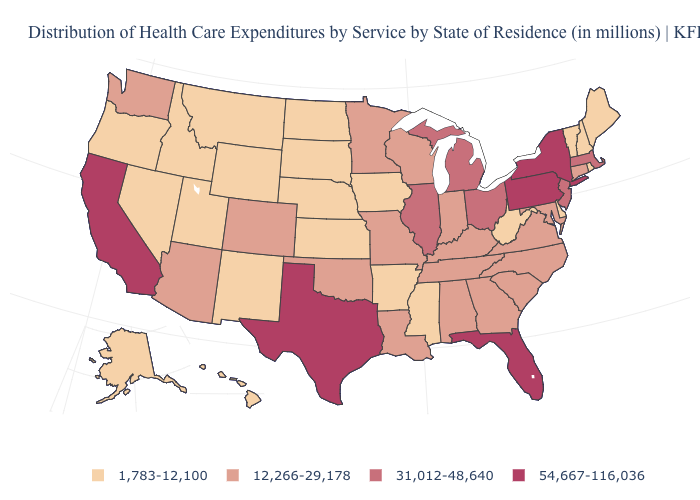Is the legend a continuous bar?
Quick response, please. No. Among the states that border Rhode Island , which have the highest value?
Be succinct. Massachusetts. What is the highest value in the USA?
Be succinct. 54,667-116,036. Name the states that have a value in the range 12,266-29,178?
Answer briefly. Alabama, Arizona, Colorado, Connecticut, Georgia, Indiana, Kentucky, Louisiana, Maryland, Minnesota, Missouri, North Carolina, Oklahoma, South Carolina, Tennessee, Virginia, Washington, Wisconsin. What is the highest value in states that border Delaware?
Write a very short answer. 54,667-116,036. Does California have the highest value in the West?
Give a very brief answer. Yes. Which states have the lowest value in the MidWest?
Quick response, please. Iowa, Kansas, Nebraska, North Dakota, South Dakota. What is the lowest value in the USA?
Keep it brief. 1,783-12,100. Which states hav the highest value in the MidWest?
Be succinct. Illinois, Michigan, Ohio. Does Michigan have the lowest value in the USA?
Quick response, please. No. Name the states that have a value in the range 54,667-116,036?
Keep it brief. California, Florida, New York, Pennsylvania, Texas. Is the legend a continuous bar?
Be succinct. No. What is the lowest value in the USA?
Give a very brief answer. 1,783-12,100. Is the legend a continuous bar?
Write a very short answer. No. What is the value of Florida?
Quick response, please. 54,667-116,036. 